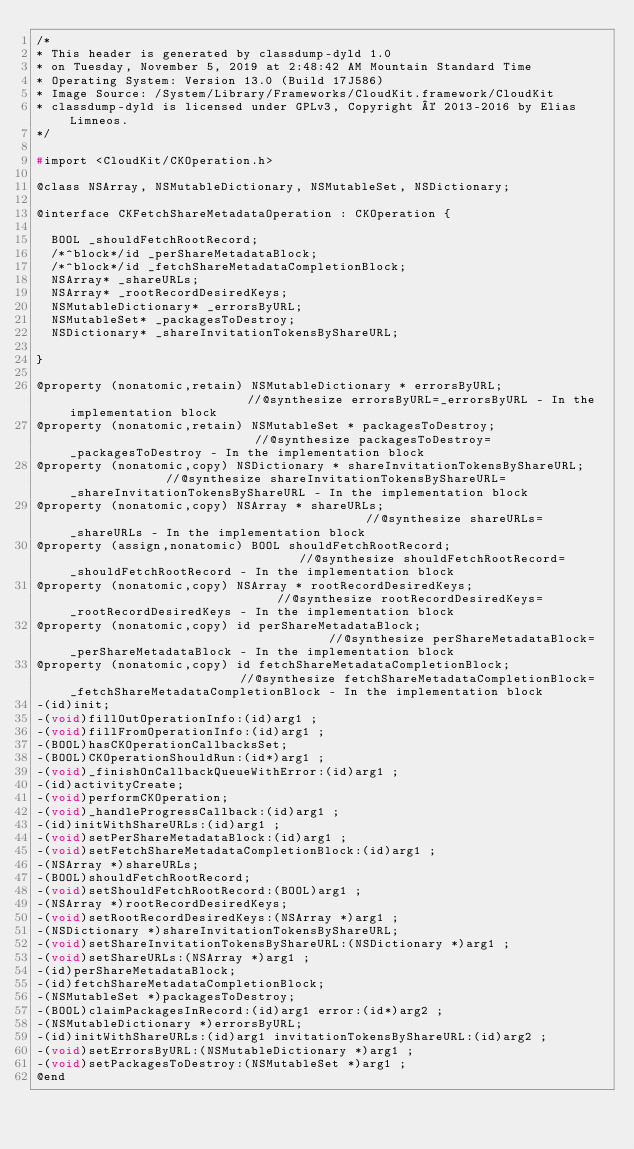<code> <loc_0><loc_0><loc_500><loc_500><_C_>/*
* This header is generated by classdump-dyld 1.0
* on Tuesday, November 5, 2019 at 2:48:42 AM Mountain Standard Time
* Operating System: Version 13.0 (Build 17J586)
* Image Source: /System/Library/Frameworks/CloudKit.framework/CloudKit
* classdump-dyld is licensed under GPLv3, Copyright © 2013-2016 by Elias Limneos.
*/

#import <CloudKit/CKOperation.h>

@class NSArray, NSMutableDictionary, NSMutableSet, NSDictionary;

@interface CKFetchShareMetadataOperation : CKOperation {

	BOOL _shouldFetchRootRecord;
	/*^block*/id _perShareMetadataBlock;
	/*^block*/id _fetchShareMetadataCompletionBlock;
	NSArray* _shareURLs;
	NSArray* _rootRecordDesiredKeys;
	NSMutableDictionary* _errorsByURL;
	NSMutableSet* _packagesToDestroy;
	NSDictionary* _shareInvitationTokensByShareURL;

}

@property (nonatomic,retain) NSMutableDictionary * errorsByURL;                         //@synthesize errorsByURL=_errorsByURL - In the implementation block
@property (nonatomic,retain) NSMutableSet * packagesToDestroy;                          //@synthesize packagesToDestroy=_packagesToDestroy - In the implementation block
@property (nonatomic,copy) NSDictionary * shareInvitationTokensByShareURL;              //@synthesize shareInvitationTokensByShareURL=_shareInvitationTokensByShareURL - In the implementation block
@property (nonatomic,copy) NSArray * shareURLs;                                         //@synthesize shareURLs=_shareURLs - In the implementation block
@property (assign,nonatomic) BOOL shouldFetchRootRecord;                                //@synthesize shouldFetchRootRecord=_shouldFetchRootRecord - In the implementation block
@property (nonatomic,copy) NSArray * rootRecordDesiredKeys;                             //@synthesize rootRecordDesiredKeys=_rootRecordDesiredKeys - In the implementation block
@property (nonatomic,copy) id perShareMetadataBlock;                                    //@synthesize perShareMetadataBlock=_perShareMetadataBlock - In the implementation block
@property (nonatomic,copy) id fetchShareMetadataCompletionBlock;                        //@synthesize fetchShareMetadataCompletionBlock=_fetchShareMetadataCompletionBlock - In the implementation block
-(id)init;
-(void)fillOutOperationInfo:(id)arg1 ;
-(void)fillFromOperationInfo:(id)arg1 ;
-(BOOL)hasCKOperationCallbacksSet;
-(BOOL)CKOperationShouldRun:(id*)arg1 ;
-(void)_finishOnCallbackQueueWithError:(id)arg1 ;
-(id)activityCreate;
-(void)performCKOperation;
-(void)_handleProgressCallback:(id)arg1 ;
-(id)initWithShareURLs:(id)arg1 ;
-(void)setPerShareMetadataBlock:(id)arg1 ;
-(void)setFetchShareMetadataCompletionBlock:(id)arg1 ;
-(NSArray *)shareURLs;
-(BOOL)shouldFetchRootRecord;
-(void)setShouldFetchRootRecord:(BOOL)arg1 ;
-(NSArray *)rootRecordDesiredKeys;
-(void)setRootRecordDesiredKeys:(NSArray *)arg1 ;
-(NSDictionary *)shareInvitationTokensByShareURL;
-(void)setShareInvitationTokensByShareURL:(NSDictionary *)arg1 ;
-(void)setShareURLs:(NSArray *)arg1 ;
-(id)perShareMetadataBlock;
-(id)fetchShareMetadataCompletionBlock;
-(NSMutableSet *)packagesToDestroy;
-(BOOL)claimPackagesInRecord:(id)arg1 error:(id*)arg2 ;
-(NSMutableDictionary *)errorsByURL;
-(id)initWithShareURLs:(id)arg1 invitationTokensByShareURL:(id)arg2 ;
-(void)setErrorsByURL:(NSMutableDictionary *)arg1 ;
-(void)setPackagesToDestroy:(NSMutableSet *)arg1 ;
@end

</code> 